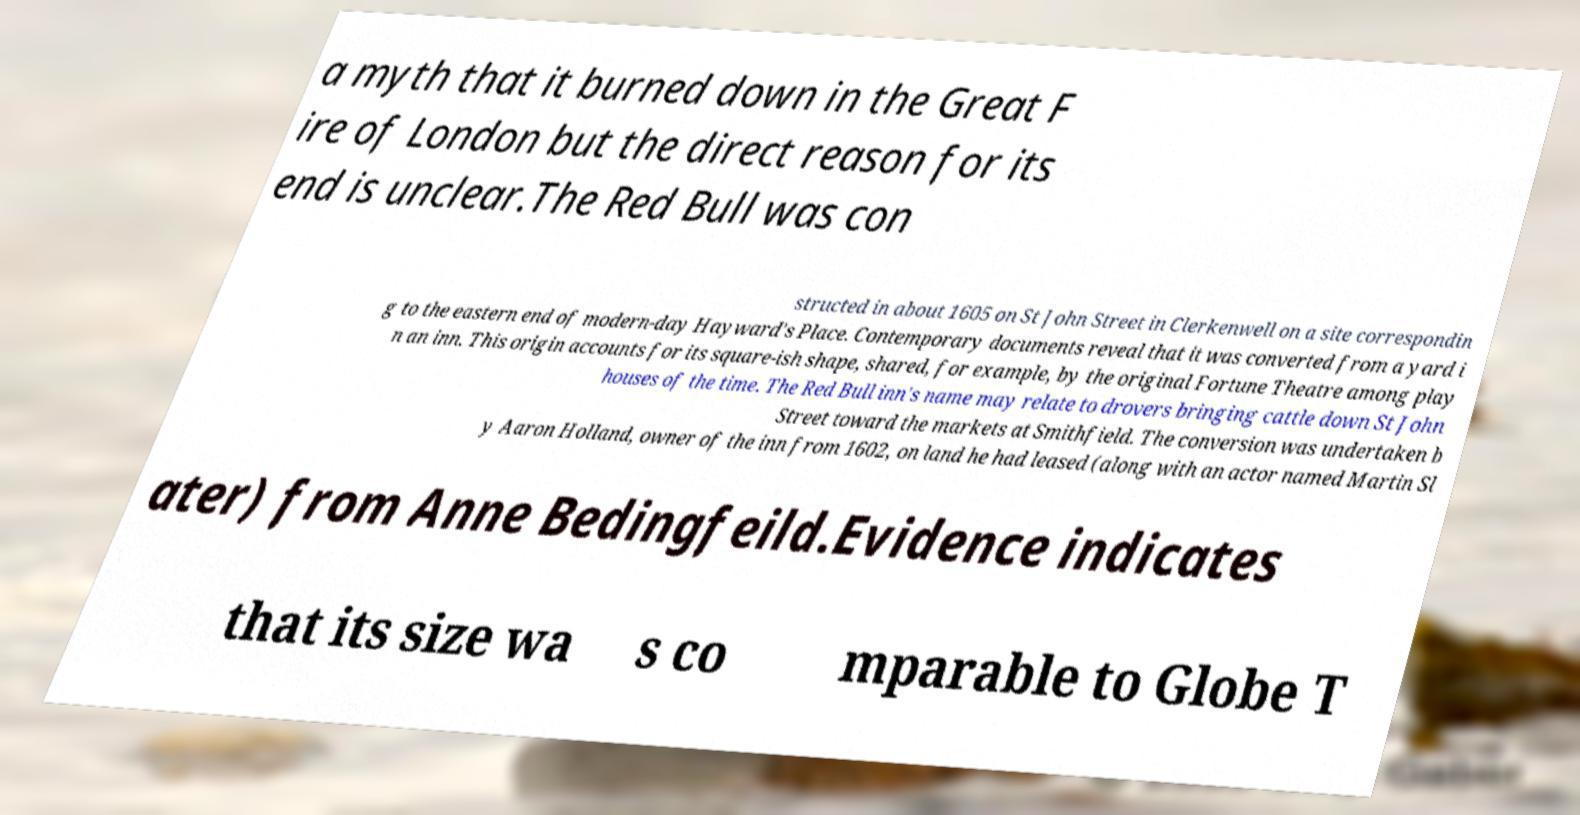Can you read and provide the text displayed in the image?This photo seems to have some interesting text. Can you extract and type it out for me? a myth that it burned down in the Great F ire of London but the direct reason for its end is unclear.The Red Bull was con structed in about 1605 on St John Street in Clerkenwell on a site correspondin g to the eastern end of modern-day Hayward's Place. Contemporary documents reveal that it was converted from a yard i n an inn. This origin accounts for its square-ish shape, shared, for example, by the original Fortune Theatre among play houses of the time. The Red Bull inn's name may relate to drovers bringing cattle down St John Street toward the markets at Smithfield. The conversion was undertaken b y Aaron Holland, owner of the inn from 1602, on land he had leased (along with an actor named Martin Sl ater) from Anne Bedingfeild.Evidence indicates that its size wa s co mparable to Globe T 